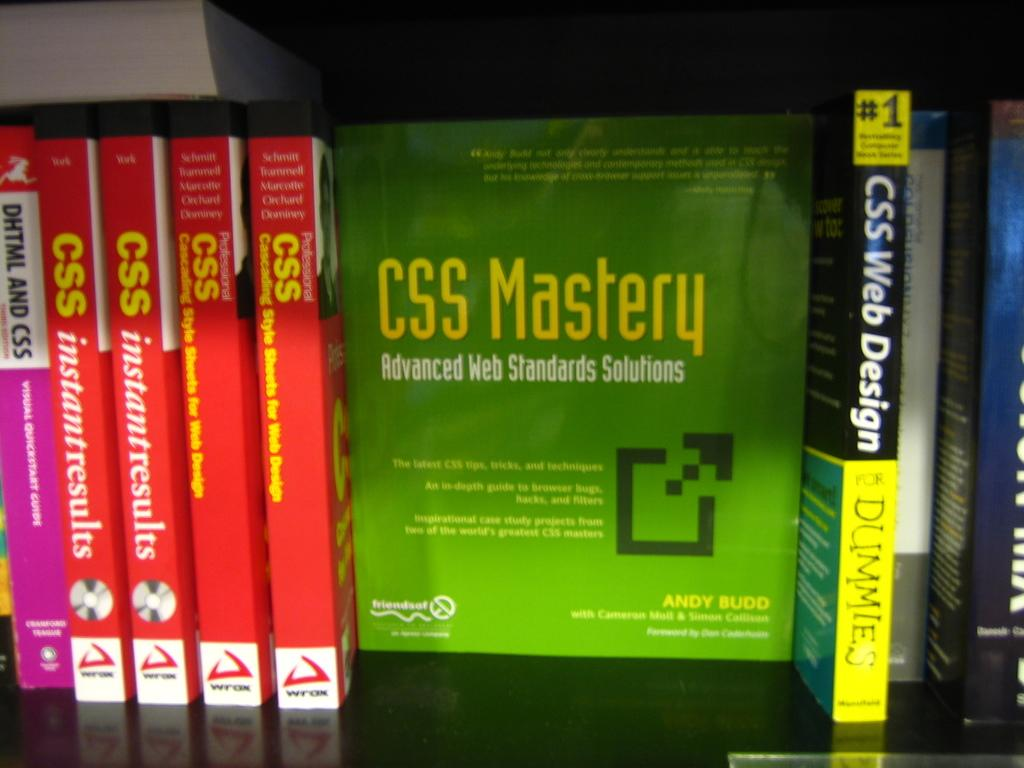<image>
Create a compact narrative representing the image presented. CSS training books of multiple levels are shown. 